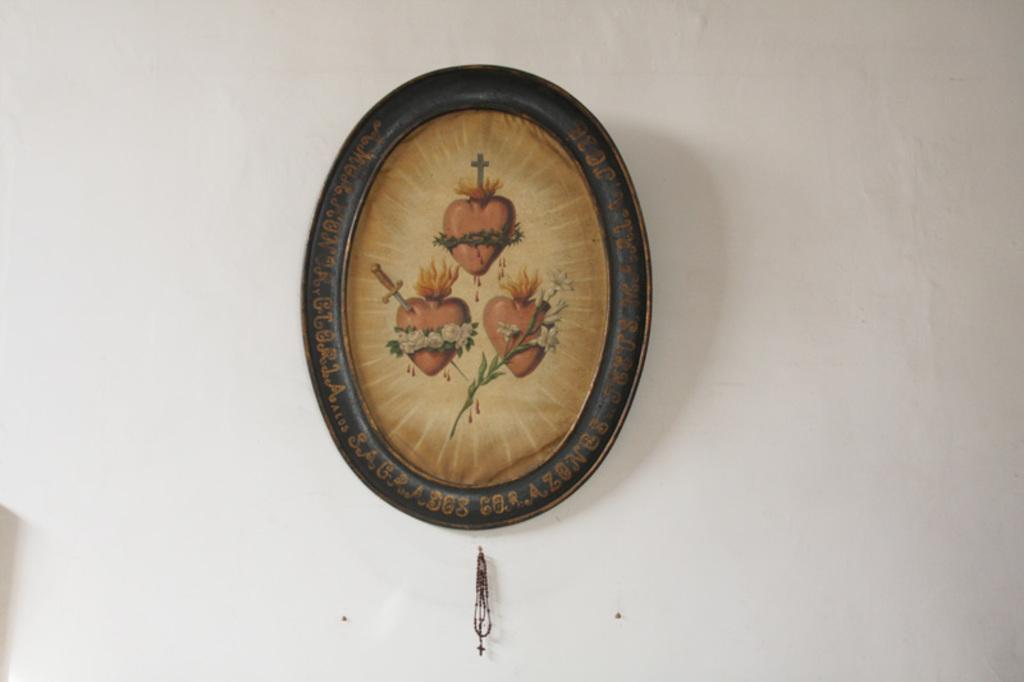What is present on the wall in the image? There is a frame and a chain on the wall in the image. Can you describe the frame in the image? The frame is in the image, but its specific details are not mentioned in the provided facts. What is the chain attached to in the image? The chain is on the wall, but its specific attachment point is not mentioned in the provided facts. Where is the train station located in the image? There is no train station present in the image; it only features a frame and a chain on the wall. What mark is visible on the chain in the image? There is no mention of a mark on the chain in the provided facts, so it cannot be determined from the image. 